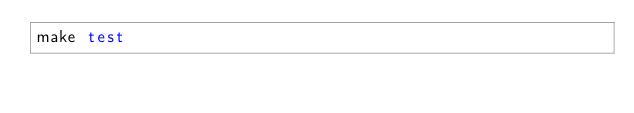Convert code to text. <code><loc_0><loc_0><loc_500><loc_500><_Bash_>make test
</code> 